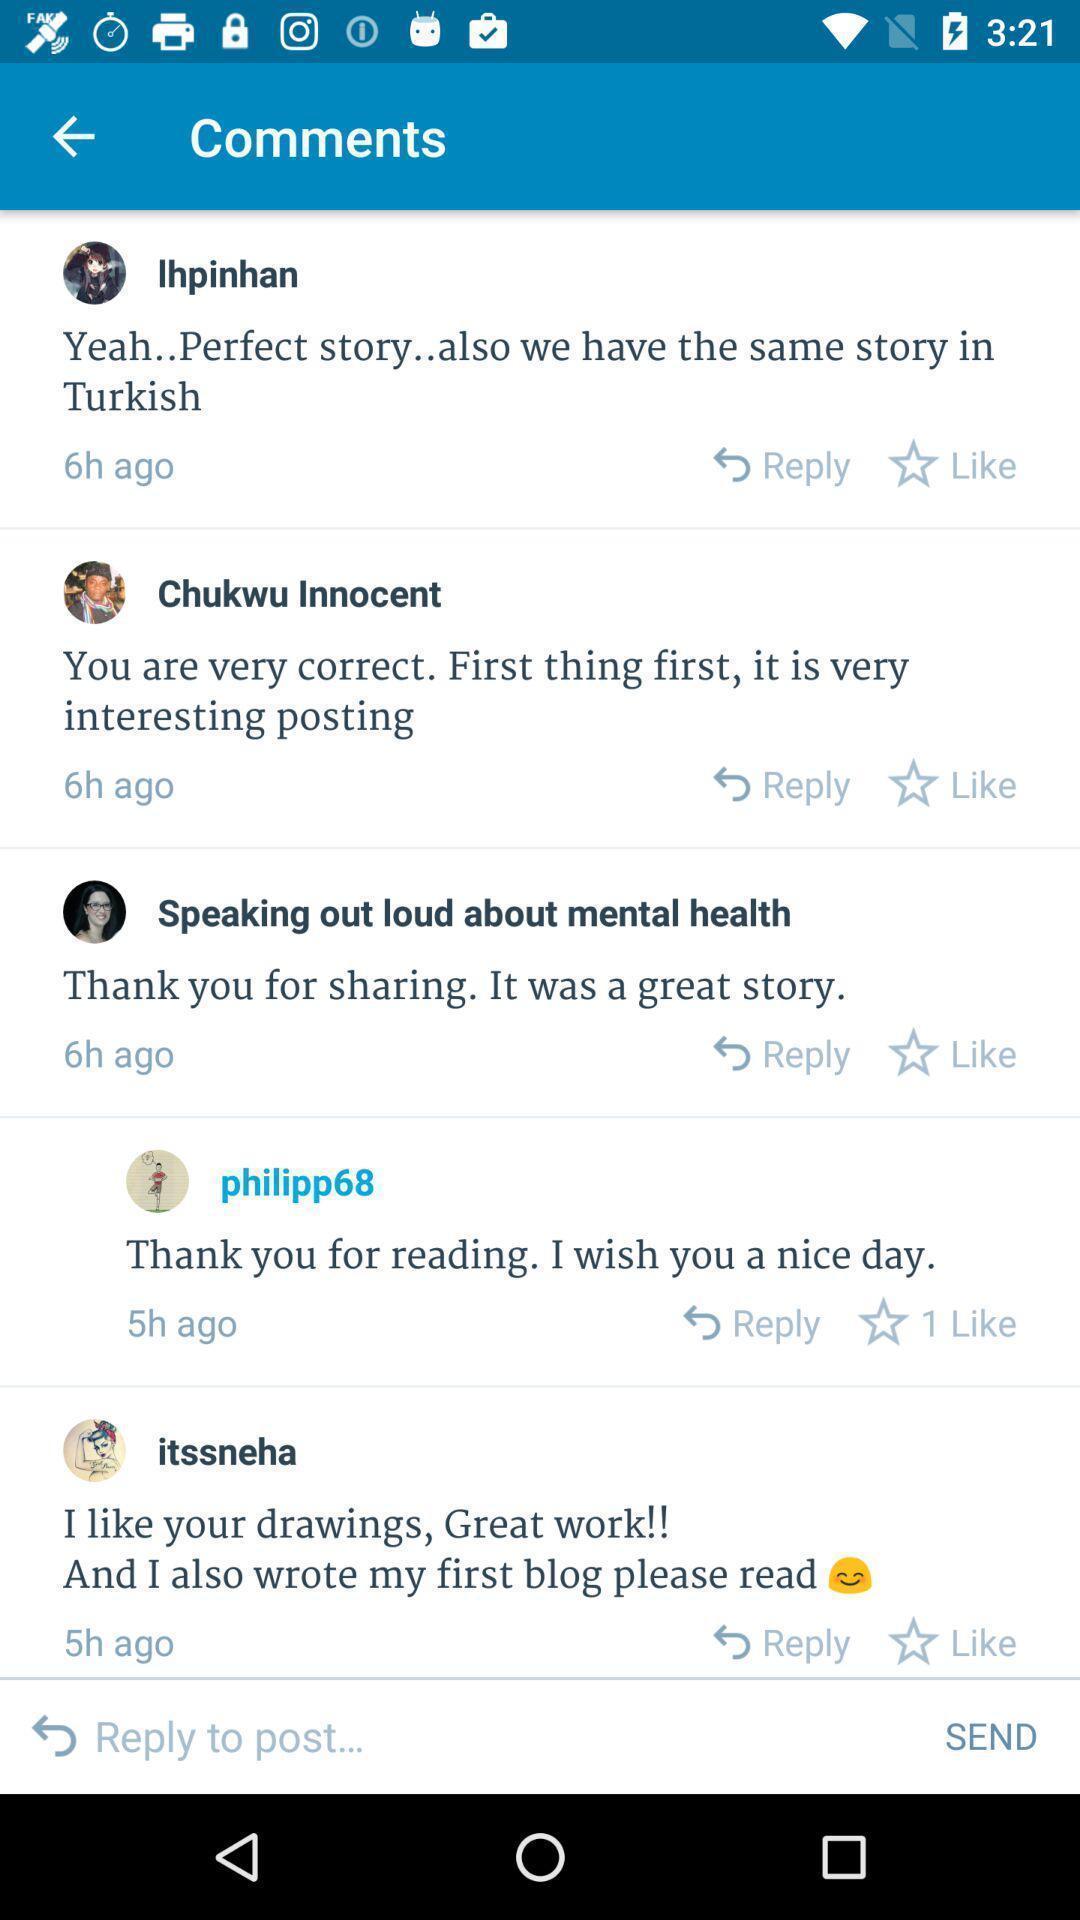Please provide a description for this image. Screen displaying multiple users comments information. 